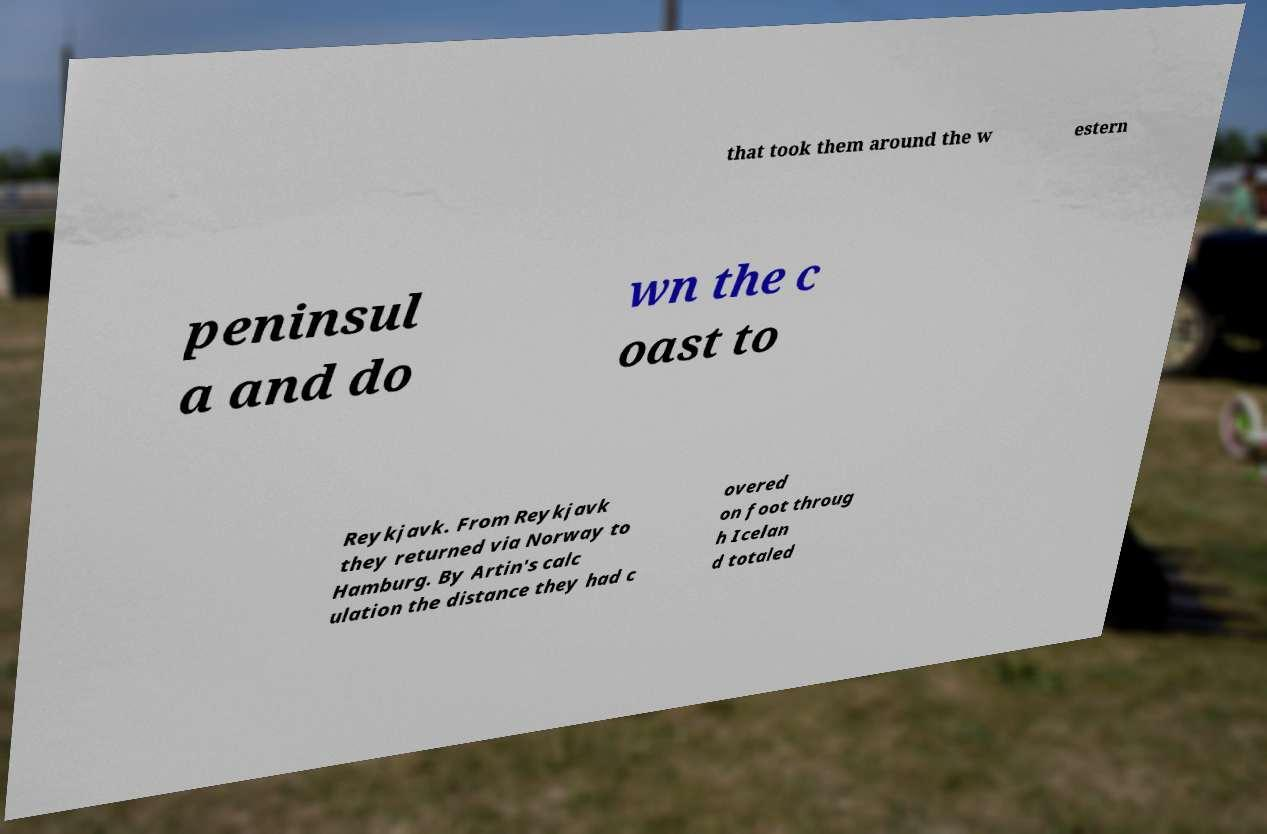I need the written content from this picture converted into text. Can you do that? that took them around the w estern peninsul a and do wn the c oast to Reykjavk. From Reykjavk they returned via Norway to Hamburg. By Artin's calc ulation the distance they had c overed on foot throug h Icelan d totaled 